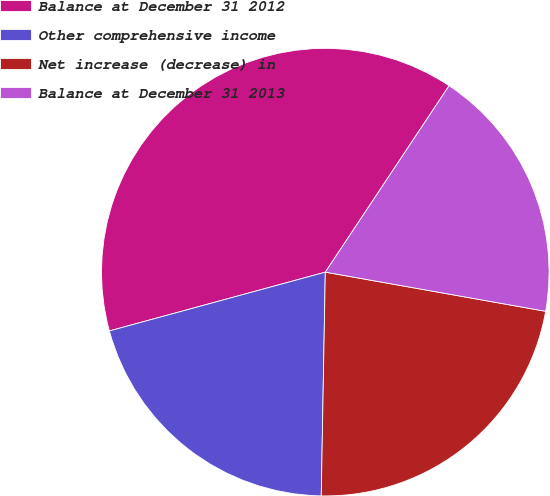<chart> <loc_0><loc_0><loc_500><loc_500><pie_chart><fcel>Balance at December 31 2012<fcel>Other comprehensive income<fcel>Net increase (decrease) in<fcel>Balance at December 31 2013<nl><fcel>38.56%<fcel>20.48%<fcel>22.49%<fcel>18.47%<nl></chart> 